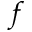Convert formula to latex. <formula><loc_0><loc_0><loc_500><loc_500>f</formula> 